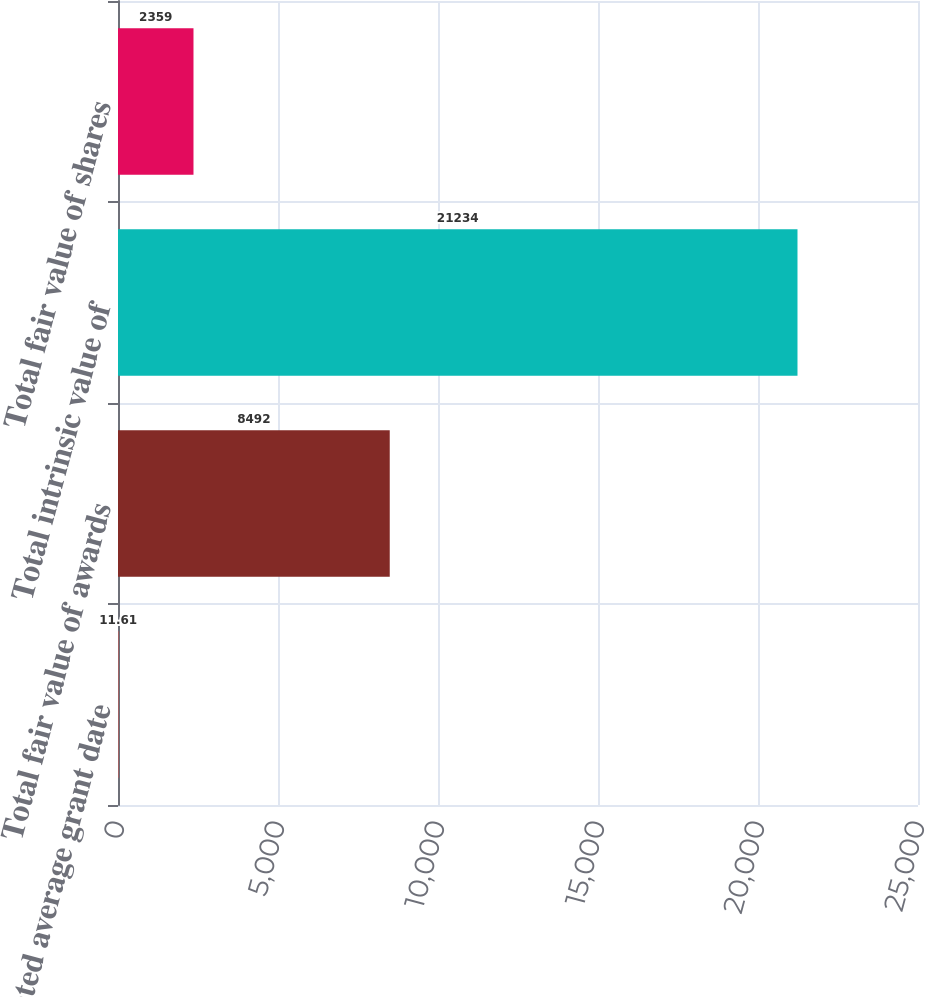Convert chart. <chart><loc_0><loc_0><loc_500><loc_500><bar_chart><fcel>Weighted average grant date<fcel>Total fair value of awards<fcel>Total intrinsic value of<fcel>Total fair value of shares<nl><fcel>11.61<fcel>8492<fcel>21234<fcel>2359<nl></chart> 